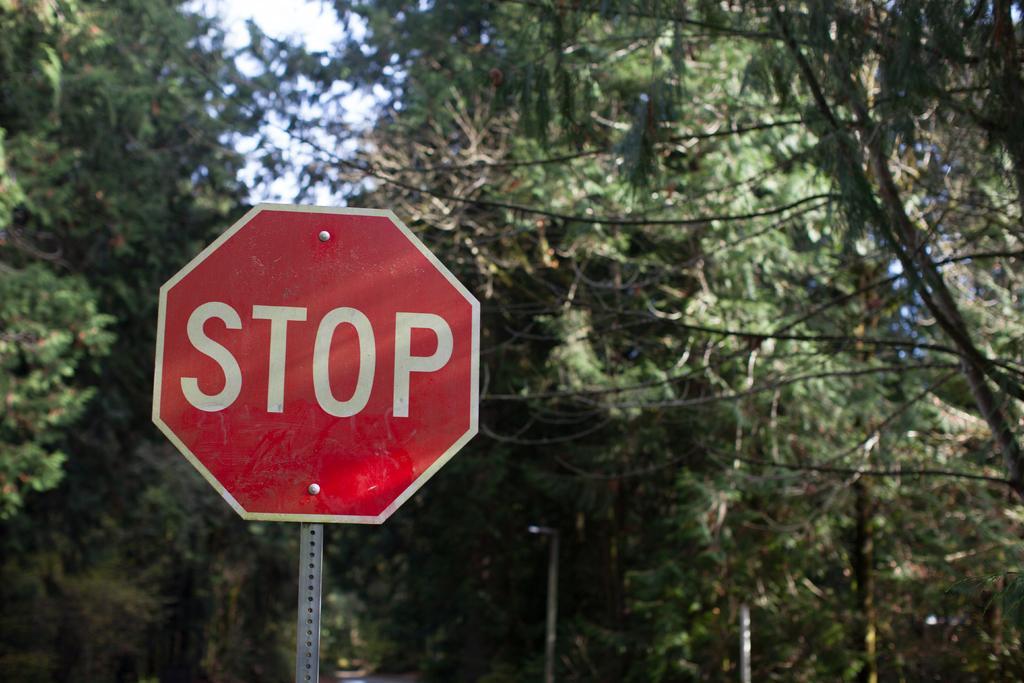How would you summarize this image in a sentence or two? In this picture, we can see a board with some text, poles, trees and the sky. 